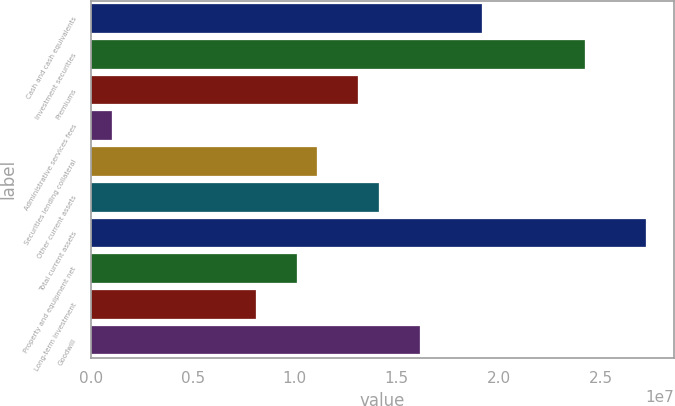Convert chart to OTSL. <chart><loc_0><loc_0><loc_500><loc_500><bar_chart><fcel>Cash and cash equivalents<fcel>Investment securities<fcel>Premiums<fcel>Administrative services fees<fcel>Securities lending collateral<fcel>Other current assets<fcel>Total current assets<fcel>Property and equipment net<fcel>Long-term investment<fcel>Goodwill<nl><fcel>1.91752e+07<fcel>2.42179e+07<fcel>1.31241e+07<fcel>1.02173e+06<fcel>1.1107e+07<fcel>1.41326e+07<fcel>2.72435e+07<fcel>1.00985e+07<fcel>8.08143e+06<fcel>1.61497e+07<nl></chart> 